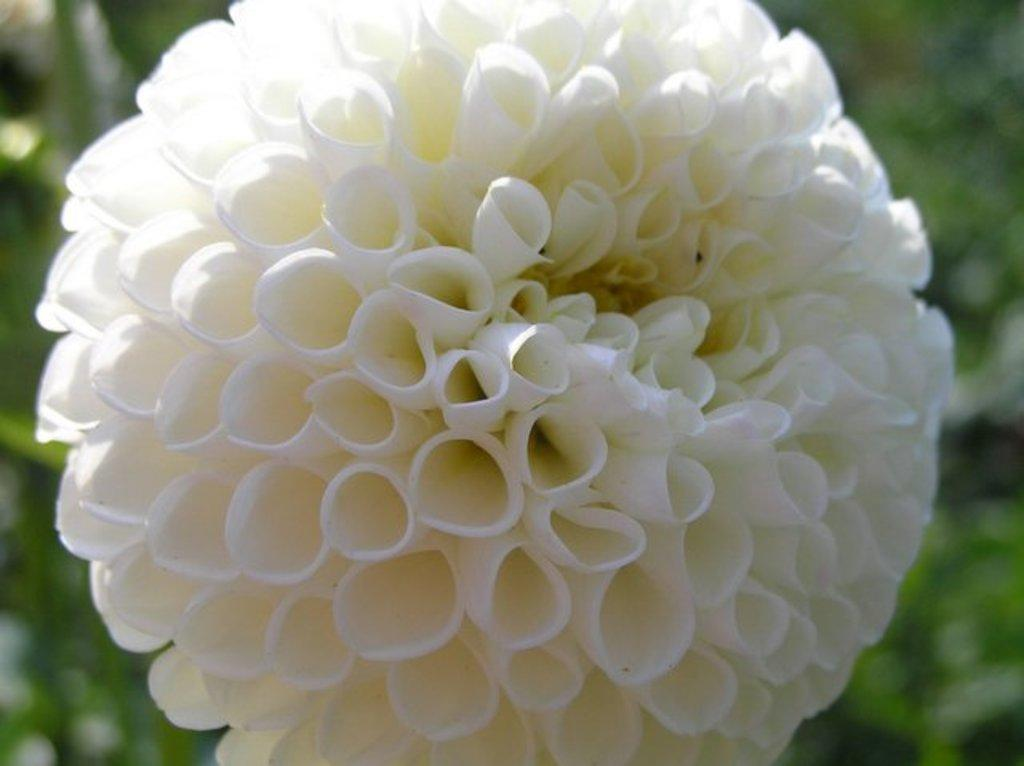What type of flower is in the image? There is a white flower in the image. Can you describe the background of the image? The background of the image is blurred. What type of lettuce is visible in the image? There is no lettuce present in the image; it features a white flower. What color is the orange in the image? There is no orange present in the image; it features a white flower. 